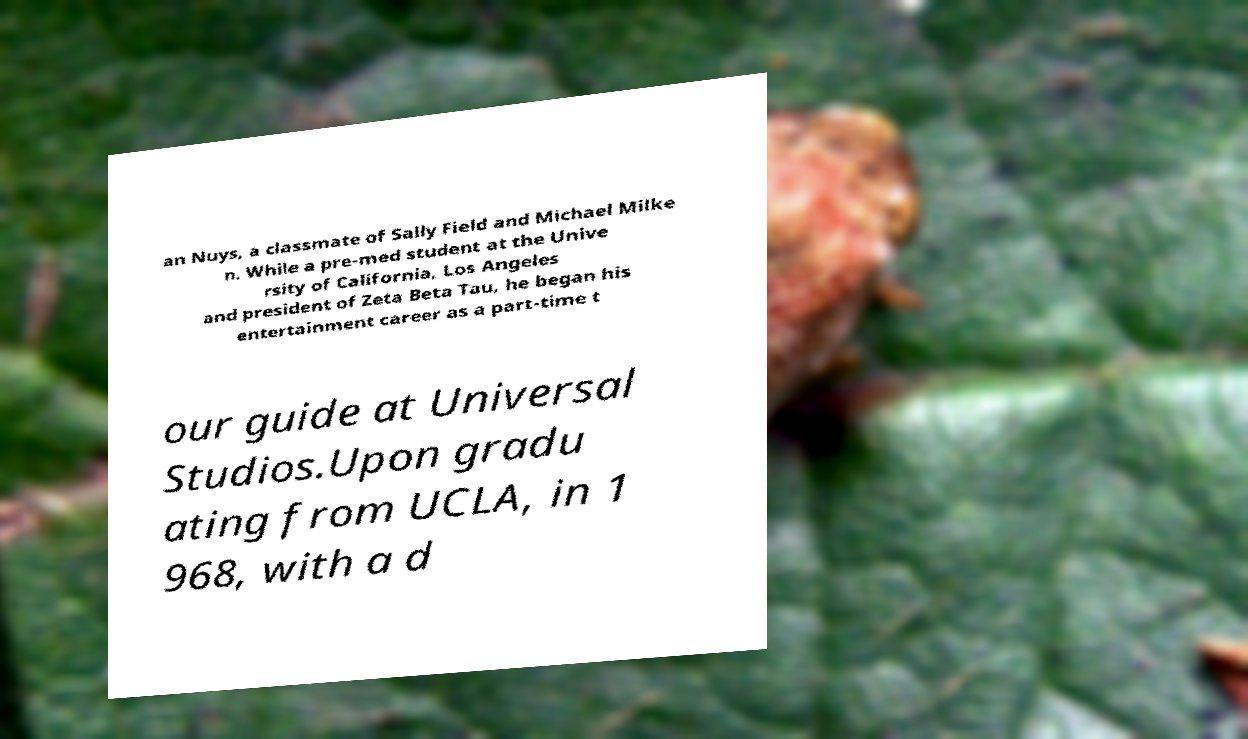There's text embedded in this image that I need extracted. Can you transcribe it verbatim? an Nuys, a classmate of Sally Field and Michael Milke n. While a pre-med student at the Unive rsity of California, Los Angeles and president of Zeta Beta Tau, he began his entertainment career as a part-time t our guide at Universal Studios.Upon gradu ating from UCLA, in 1 968, with a d 